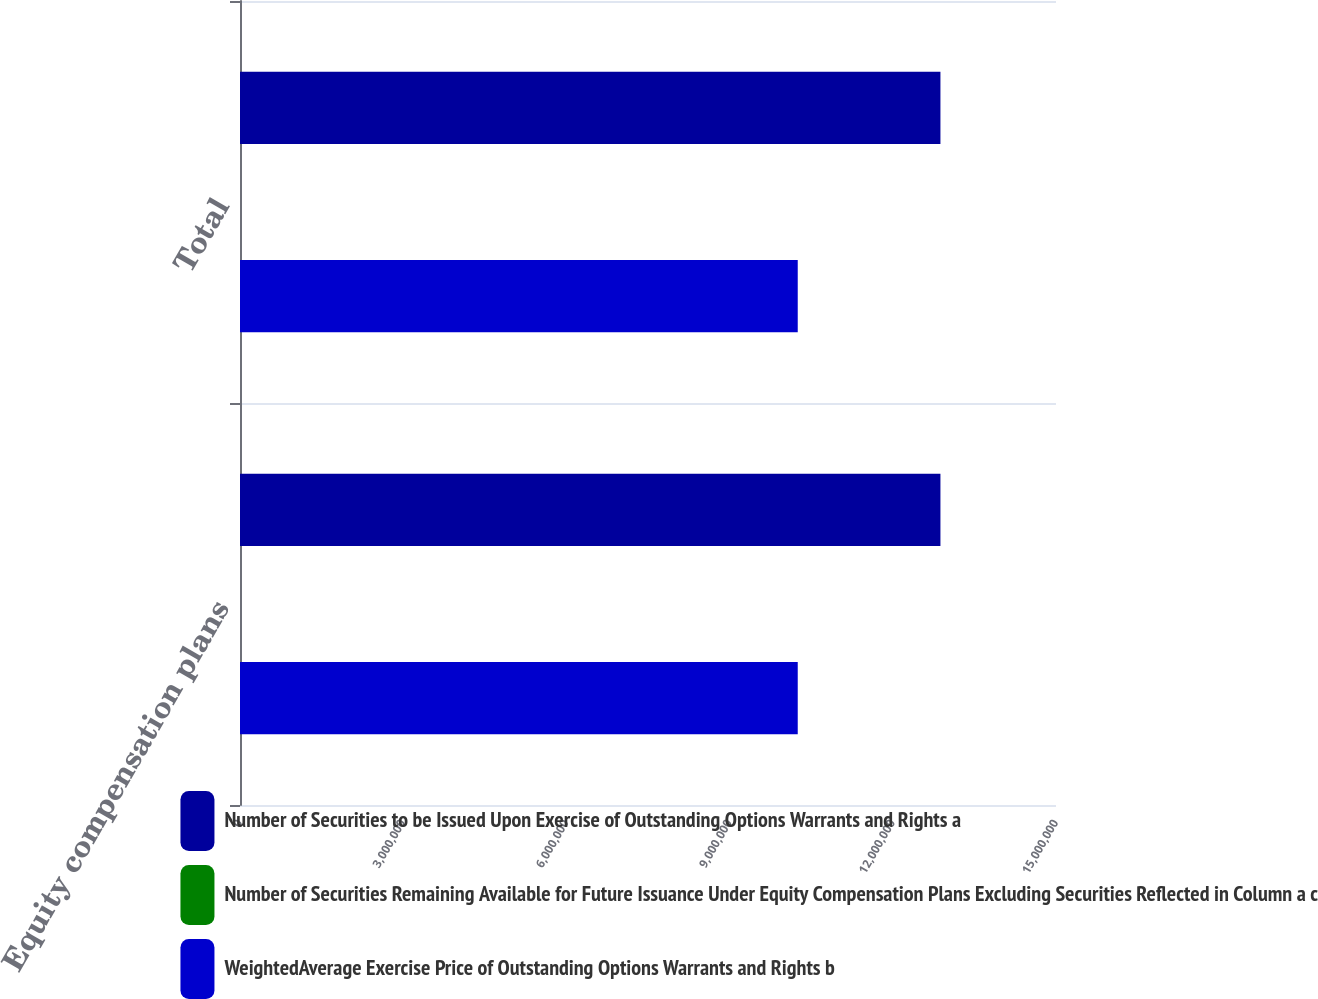Convert chart to OTSL. <chart><loc_0><loc_0><loc_500><loc_500><stacked_bar_chart><ecel><fcel>Equity compensation plans<fcel>Total<nl><fcel>Number of Securities to be Issued Upon Exercise of Outstanding Options Warrants and Rights a<fcel>1.28756e+07<fcel>1.28756e+07<nl><fcel>Number of Securities Remaining Available for Future Issuance Under Equity Compensation Plans Excluding Securities Reflected in Column a c<fcel>38.6<fcel>38.6<nl><fcel>WeightedAverage Exercise Price of Outstanding Options Warrants and Rights b<fcel>1.02526e+07<fcel>1.02526e+07<nl></chart> 